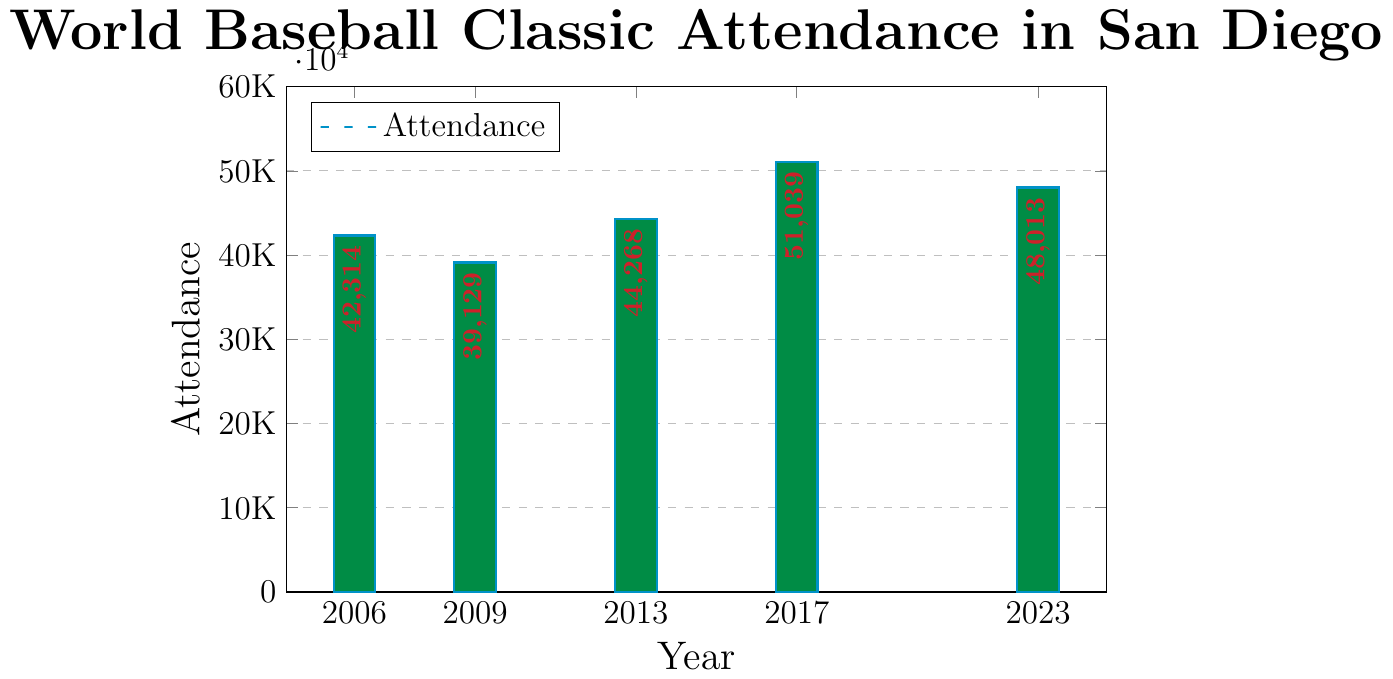What's the highest attendance figure shown in the chart? To find the highest attendance, locate the tallest bar on the chart and read its value. The tallest bar is labeled 51,039 for the year 2017.
Answer: 51,039 Which year had the lowest attendance? Identify the shortest bar on the chart. The shortest bar is for the year 2009, with an attendance of 39,129.
Answer: 2009 What is the difference in attendance between 2017 and 2023? Find attendance figures for 2017 and 2023, which are 51,039 and 48,013, respectively. Subtract the 2023 figure from the 2017 figure: 51,039 - 48,013 = 3,026.
Answer: 3,026 What is the average attendance over the years shown? Sum the attendance figures (42,314 + 39,129 + 44,268 + 51,039 + 48,013 = 224,763) and divide by the number of years (5). The average is 224,763 / 5 = 44,952.6.
Answer: 44,952.6 How much did the attendance increase from 2009 to 2013? Find attendance for 2009 (39,129) and 2013 (44,268). Subtract the 2009 attendance from the 2013 attendance: 44,268 - 39,129 = 5,139.
Answer: 5,139 Which year had an attendance that was closest to the average attendance? The average attendance is 44,952.6. Compare each year's attendance to this average: 2006 (42,314), 2009 (39,129), 2013 (44,268), 2017 (51,039), 2023 (48,013). The year 2013 with an attendance of 44,268 is closest to the average.
Answer: 2013 What is the total attendance for all the years combined? Sum all the attendance figures: 42,314 + 39,129 + 44,268 + 51,039 + 48,013 = 224,763.
Answer: 224,763 Place the years in order from highest to lowest attendance. Arrange the years based on their attendance values: 2017 (51,039), 2023 (48,013), 2013 (44,268), 2006 (42,314), 2009 (39,129).
Answer: 2017, 2023, 2013, 2006, 2009 What is the median attendance figure? Arrange the attendance figures in ascending order: 39,129 (2009), 42,314 (2006), 44,268 (2013), 48,013 (2023), 51,039 (2017). The middle value in this ordered list is 44,268.
Answer: 44,268 